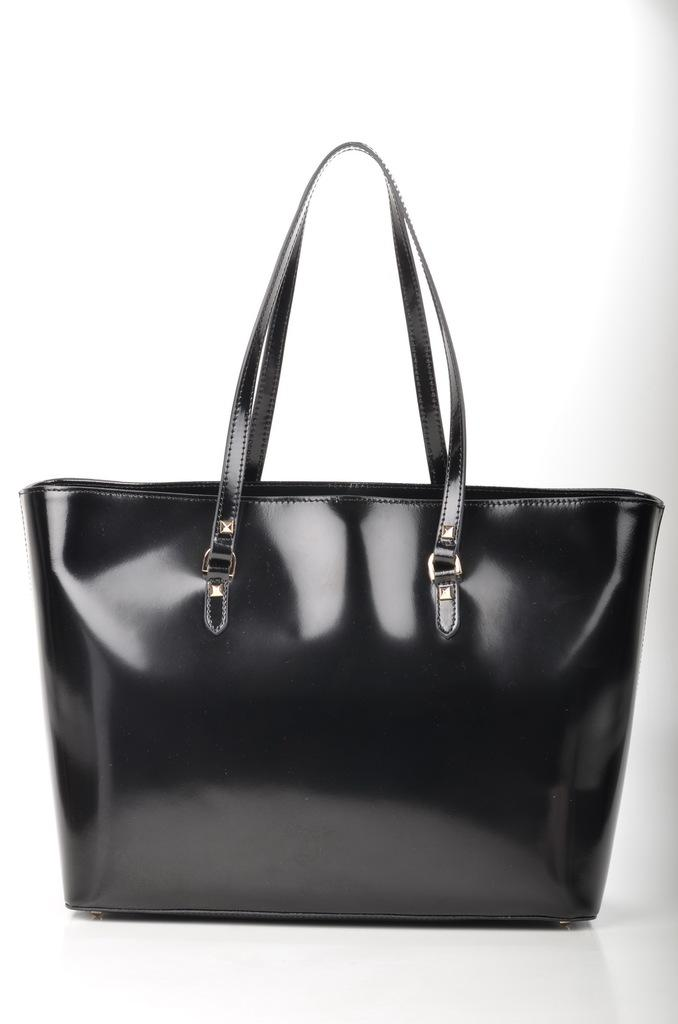What type of accessory is present in the image? There is a black handbag in the image. What design element can be seen on the handbag? The handbag has strips. Can you find the receipt for the handbag in the image? There is no receipt present in the image, as it only shows the black handbag with strips. 